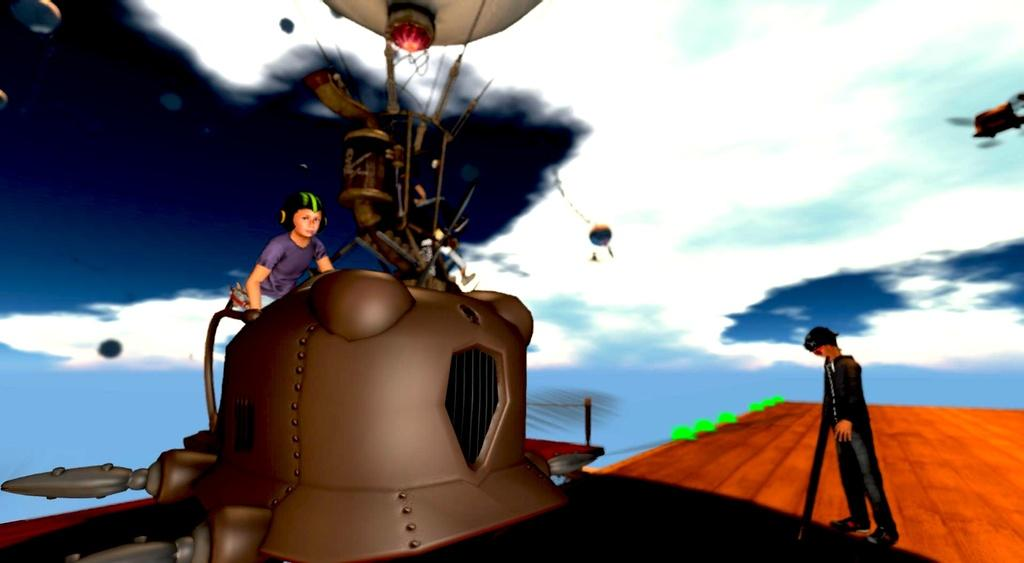What type of image is being described? The image appears to be animated. What is the person in the image doing? The person is sitting on a machine in the image. What can be seen in the background of the image? There are clouds in the sky in the background of the image. What is visible at the bottom of the image? There is a floor visible at the bottom of the image. Is there an umbrella covering the person sitting on the machine in the image? There is no umbrella present in the image. How does the machine expand in the image? The machine does not expand in the image; it is stationary with the person sitting on it. 